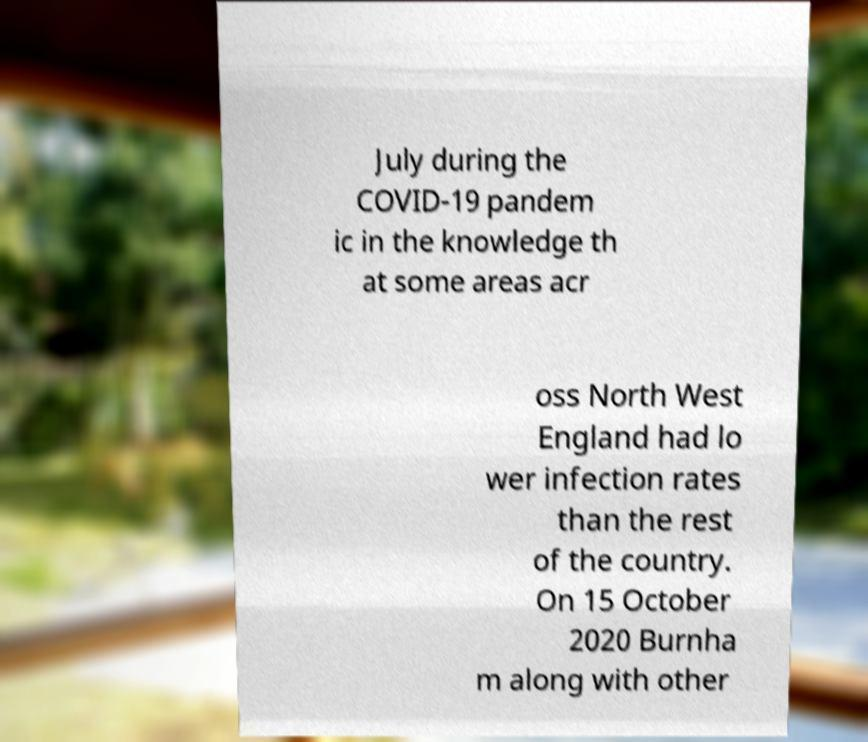Please identify and transcribe the text found in this image. July during the COVID-19 pandem ic in the knowledge th at some areas acr oss North West England had lo wer infection rates than the rest of the country. On 15 October 2020 Burnha m along with other 